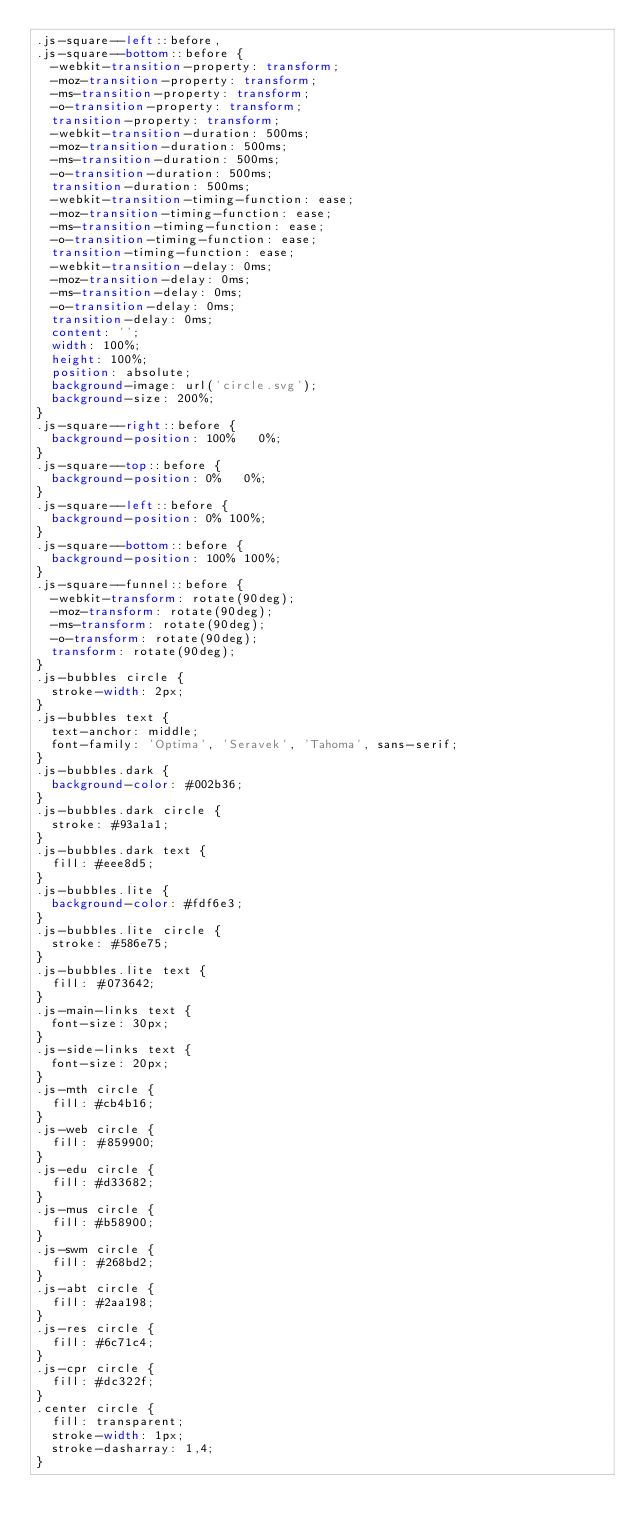Convert code to text. <code><loc_0><loc_0><loc_500><loc_500><_CSS_>.js-square--left::before,
.js-square--bottom::before {
  -webkit-transition-property: transform;
  -moz-transition-property: transform;
  -ms-transition-property: transform;
  -o-transition-property: transform;
  transition-property: transform;
  -webkit-transition-duration: 500ms;
  -moz-transition-duration: 500ms;
  -ms-transition-duration: 500ms;
  -o-transition-duration: 500ms;
  transition-duration: 500ms;
  -webkit-transition-timing-function: ease;
  -moz-transition-timing-function: ease;
  -ms-transition-timing-function: ease;
  -o-transition-timing-function: ease;
  transition-timing-function: ease;
  -webkit-transition-delay: 0ms;
  -moz-transition-delay: 0ms;
  -ms-transition-delay: 0ms;
  -o-transition-delay: 0ms;
  transition-delay: 0ms;
  content: '';
  width: 100%;
  height: 100%;
  position: absolute;
  background-image: url('circle.svg');
  background-size: 200%;
}
.js-square--right::before {
  background-position: 100%   0%;
}
.js-square--top::before {
  background-position: 0%   0%;
}
.js-square--left::before {
  background-position: 0% 100%;
}
.js-square--bottom::before {
  background-position: 100% 100%;
}
.js-square--funnel::before {
  -webkit-transform: rotate(90deg);
  -moz-transform: rotate(90deg);
  -ms-transform: rotate(90deg);
  -o-transform: rotate(90deg);
  transform: rotate(90deg);
}
.js-bubbles circle {
  stroke-width: 2px;
}
.js-bubbles text {
  text-anchor: middle;
  font-family: 'Optima', 'Seravek', 'Tahoma', sans-serif;
}
.js-bubbles.dark {
  background-color: #002b36;
}
.js-bubbles.dark circle {
  stroke: #93a1a1;
}
.js-bubbles.dark text {
  fill: #eee8d5;
}
.js-bubbles.lite {
  background-color: #fdf6e3;
}
.js-bubbles.lite circle {
  stroke: #586e75;
}
.js-bubbles.lite text {
  fill: #073642;
}
.js-main-links text {
  font-size: 30px;
}
.js-side-links text {
  font-size: 20px;
}
.js-mth circle {
  fill: #cb4b16;
}
.js-web circle {
  fill: #859900;
}
.js-edu circle {
  fill: #d33682;
}
.js-mus circle {
  fill: #b58900;
}
.js-swm circle {
  fill: #268bd2;
}
.js-abt circle {
  fill: #2aa198;
}
.js-res circle {
  fill: #6c71c4;
}
.js-cpr circle {
  fill: #dc322f;
}
.center circle {
  fill: transparent;
  stroke-width: 1px;
  stroke-dasharray: 1,4;
}
</code> 